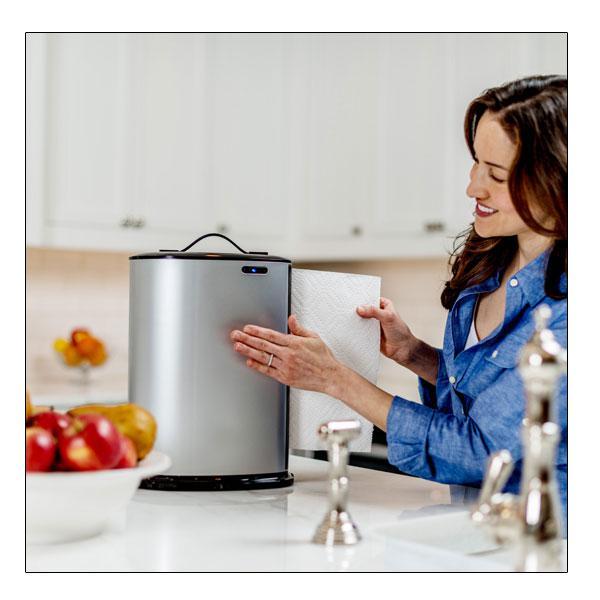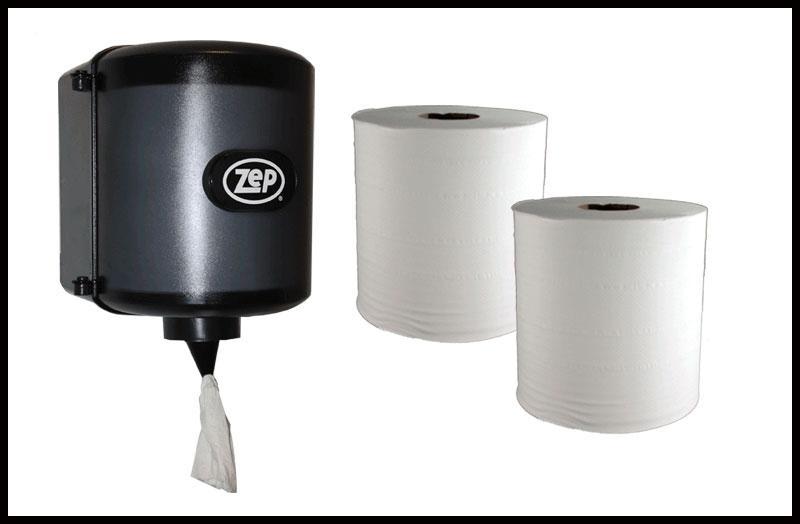The first image is the image on the left, the second image is the image on the right. Assess this claim about the two images: "The image on the right shows a person reaching for a disposable paper towel.". Correct or not? Answer yes or no. No. The first image is the image on the left, the second image is the image on the right. For the images displayed, is the sentence "In one of the image there are two paper rolls next to a paper towel dispenser." factually correct? Answer yes or no. Yes. 